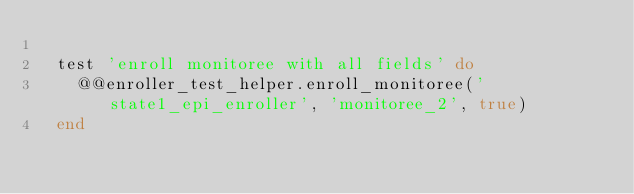<code> <loc_0><loc_0><loc_500><loc_500><_Ruby_>
  test 'enroll monitoree with all fields' do
    @@enroller_test_helper.enroll_monitoree('state1_epi_enroller', 'monitoree_2', true)
  end
</code> 